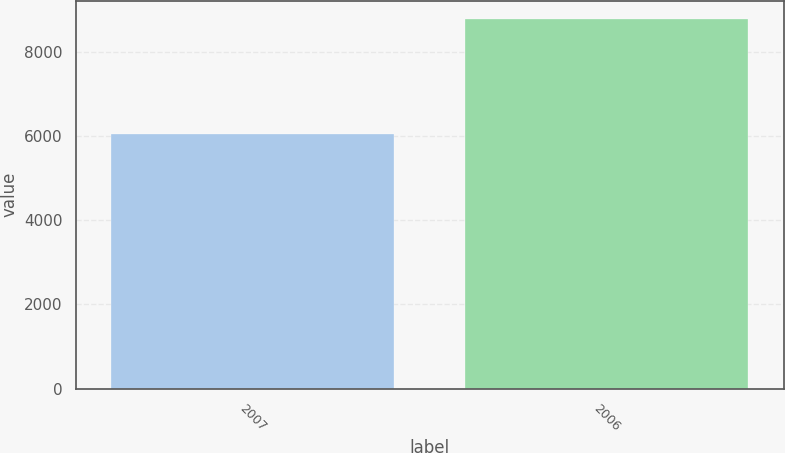Convert chart to OTSL. <chart><loc_0><loc_0><loc_500><loc_500><bar_chart><fcel>2007<fcel>2006<nl><fcel>6047<fcel>8777<nl></chart> 